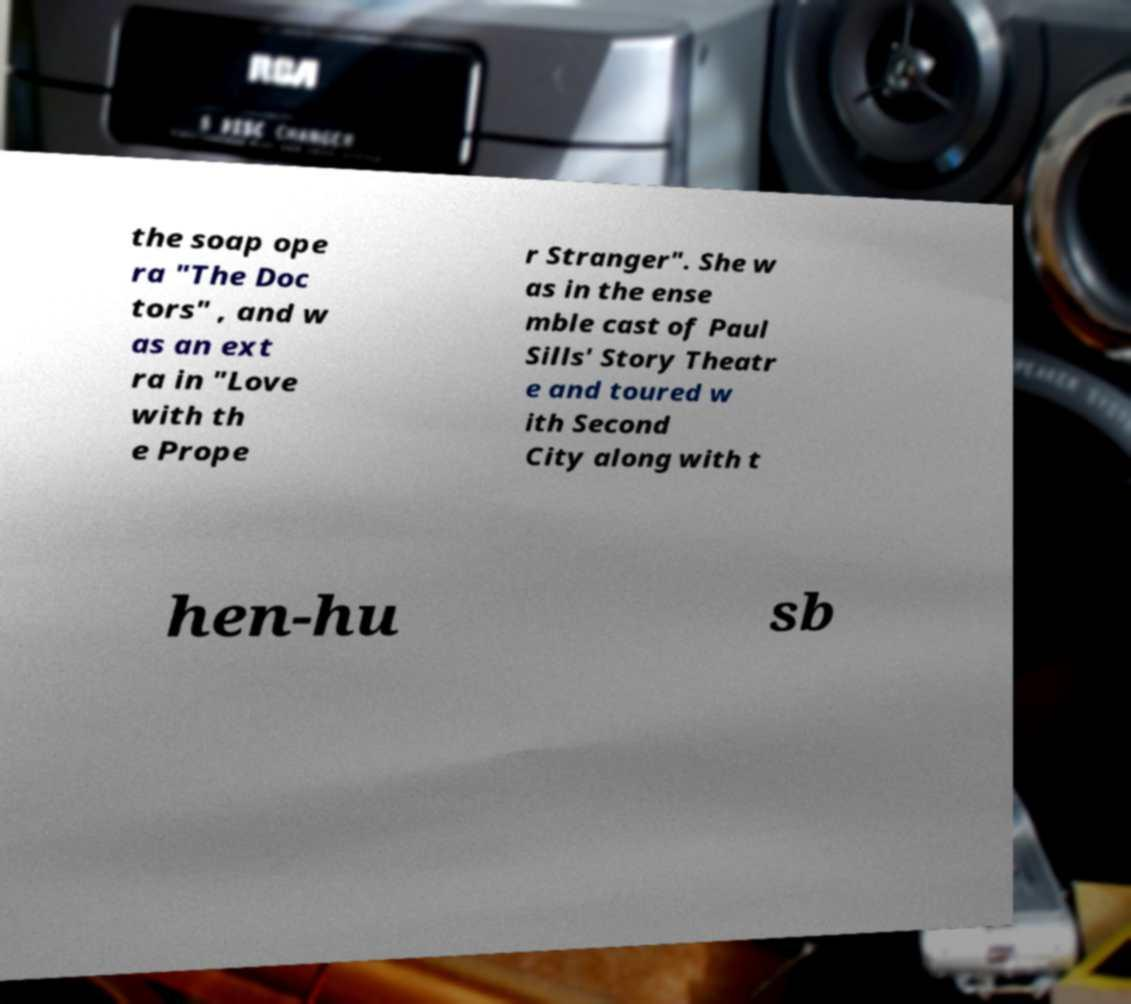Could you extract and type out the text from this image? the soap ope ra "The Doc tors" , and w as an ext ra in "Love with th e Prope r Stranger". She w as in the ense mble cast of Paul Sills' Story Theatr e and toured w ith Second City along with t hen-hu sb 